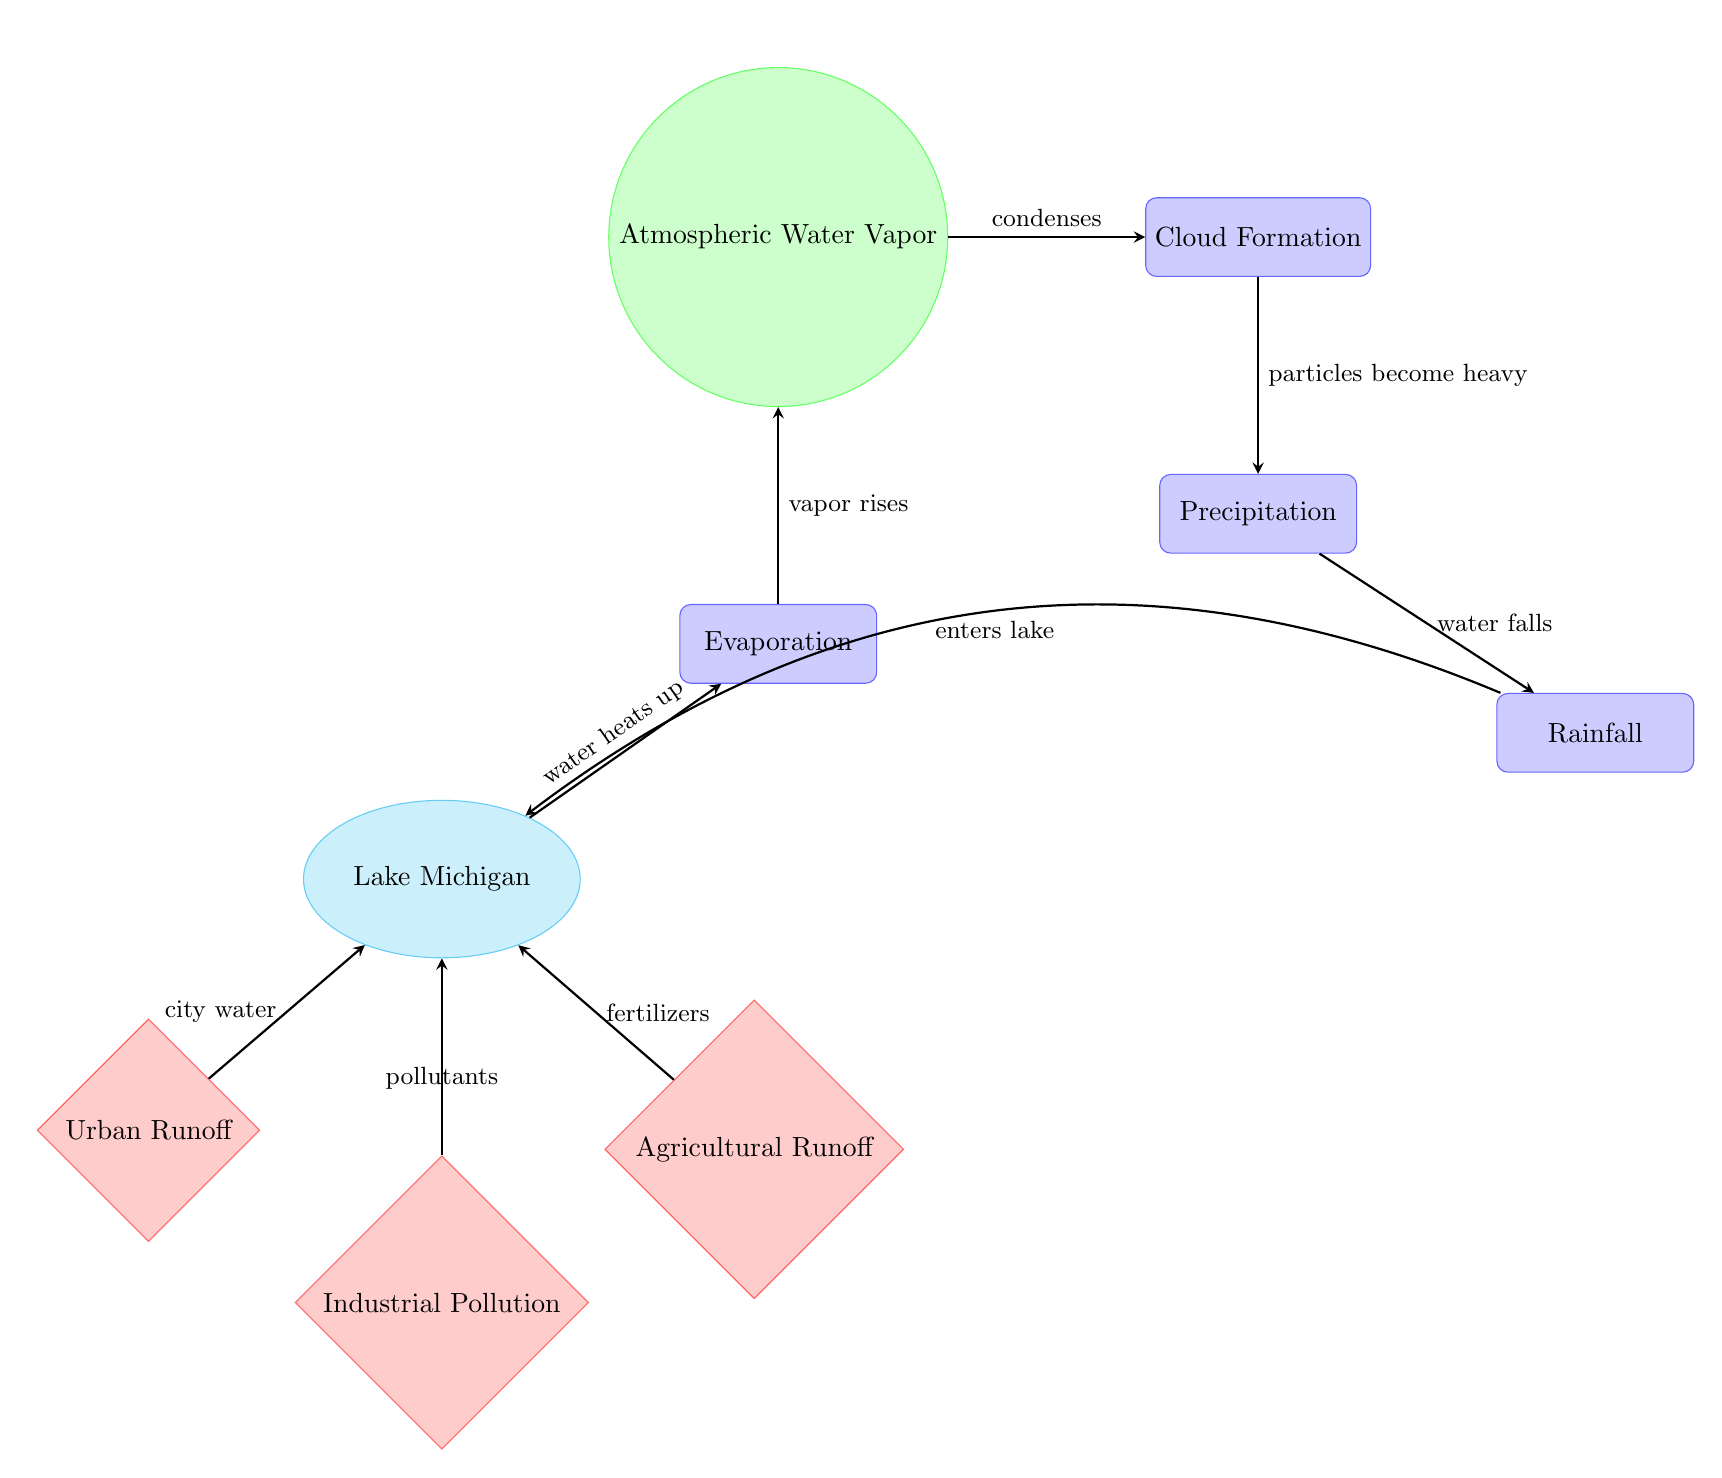What is the body of water depicted in the diagram? The diagram clearly labels the main component at the center as "Lake Michigan", representing the body of water involved in the water cycle dynamics.
Answer: Lake Michigan How many human impact nodes are present in the diagram? The diagram shows three distinct human impact nodes: Urban Runoff, Industrial Pollution, and Agricultural Runoff, which can be counted directly from their representation.
Answer: 3 What process follows evaporation in the water cycle according to the diagram? After evaporation, the next process represented is "Atmospheric Water Vapor", indicating the transformation of water into vapor which then rises into the atmosphere.
Answer: Atmospheric Water Vapor Which human impact contributes pollutants to the lake? The diagram indicates that "Industrial Pollution" contributes pollutants to Lake Michigan, as evidenced by the directed arrow pointing from the industrial impact node to the lake.
Answer: Industrial Pollution What does the cloud formation process indicate in the sequence? The "Cloud Formation" process indicates that after atmospheric water vapor condenses, it leads to the formation of clouds in the water cycle, which is depicted flowing from the vapor node to the cloud node.
Answer: Cloud Formation Which node represents rainfall in the diagram? "Rainfall" is explicitly labeled as a process in the diagram, following the precipitation node, making it clear where the actual precipitation occurs in the sequence.
Answer: Rainfall What is the ultimate source of water returning to the lake after rain? The diagram illustrates the flow from "Rainfall" back to "Lake Michigan", confirming that rainfall is the source of water returning to the lake after precipitation.
Answer: Lake Michigan How does urban runoff interact with the lake according to the diagram? The diagram shows an arrow leading from "Urban Runoff" to "Lake Michigan", indicating that city water and runoff directly enter the lake.
Answer: City water What happens to the vapor after it rises in the diagram? According to the diagram, after "Atmo... Water Vapor" rises, it undergoes "Cloud Formation", which suggests that vapor contributes to cloud development as part of the water cycle process.
Answer: Cloud Formation 